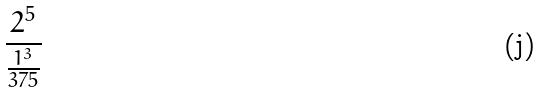Convert formula to latex. <formula><loc_0><loc_0><loc_500><loc_500>\frac { 2 ^ { 5 } } { \frac { 1 ^ { 3 } } { 3 7 5 } }</formula> 